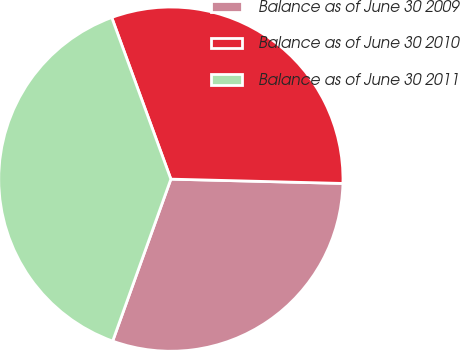<chart> <loc_0><loc_0><loc_500><loc_500><pie_chart><fcel>Balance as of June 30 2009<fcel>Balance as of June 30 2010<fcel>Balance as of June 30 2011<nl><fcel>30.09%<fcel>30.98%<fcel>38.93%<nl></chart> 